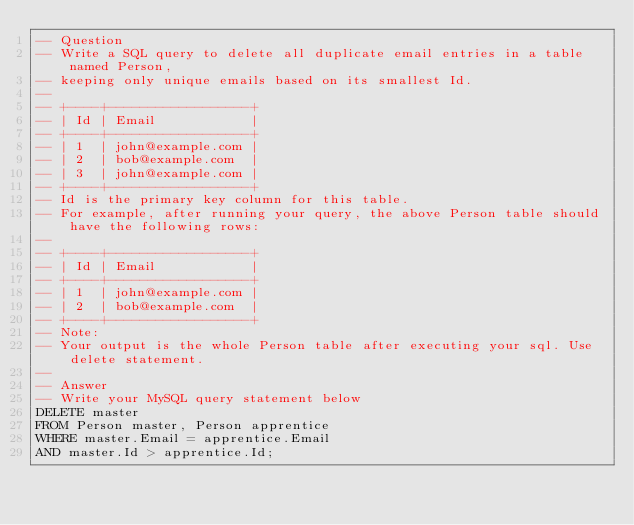<code> <loc_0><loc_0><loc_500><loc_500><_SQL_>-- Question
-- Write a SQL query to delete all duplicate email entries in a table named Person,
-- keeping only unique emails based on its smallest Id.
--
-- +----+------------------+
-- | Id | Email            |
-- +----+------------------+
-- | 1  | john@example.com |
-- | 2  | bob@example.com  |
-- | 3  | john@example.com |
-- +----+------------------+
-- Id is the primary key column for this table.
-- For example, after running your query, the above Person table should have the following rows:
--
-- +----+------------------+
-- | Id | Email            |
-- +----+------------------+
-- | 1  | john@example.com |
-- | 2  | bob@example.com  |
-- +----+------------------+
-- Note:
-- Your output is the whole Person table after executing your sql. Use delete statement.
--
-- Answer
-- Write your MySQL query statement below
DELETE master
FROM Person master, Person apprentice
WHERE master.Email = apprentice.Email
AND master.Id > apprentice.Id;</code> 